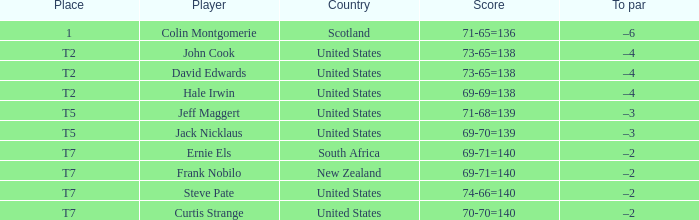Frank Nobilo plays for what country? New Zealand. 